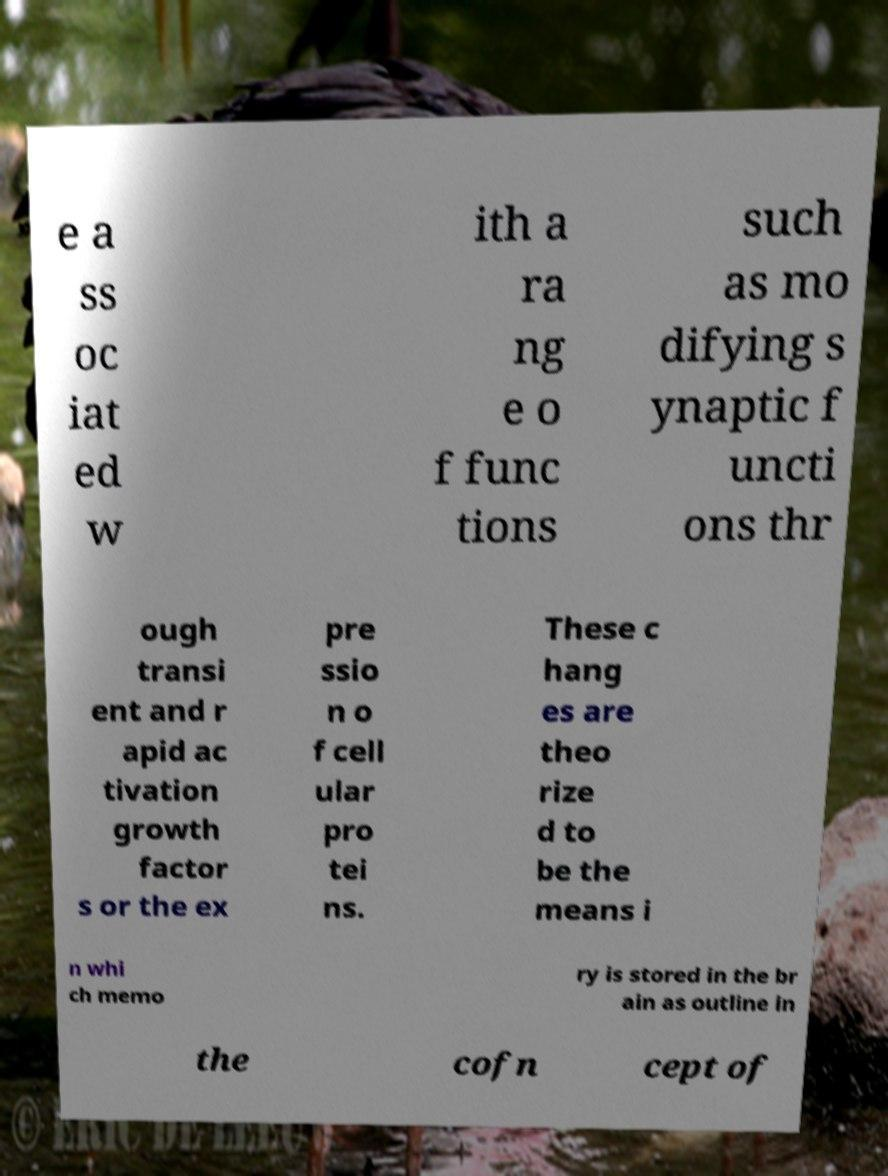What might the phrase 'the expression of cellular proteins' imply in the context of memory storage? The 'expression of cellular proteins' likely refers to the production and regulation of proteins within cells, which can be crucial for memory. Proteins play a pivotal role in maintaining the structure and function of brain cells, potentially impacting how memories are formed and retained. How does this relate to understanding diseases like Alzheimer's? Understanding the expression of cellular proteins in brain cells is crucial for unraveling the mechanisms of neurodegenerative diseases like Alzheimer's. Abnormal protein expression can lead to impaired memory and cognitive functions, hallmarks of such conditions. 